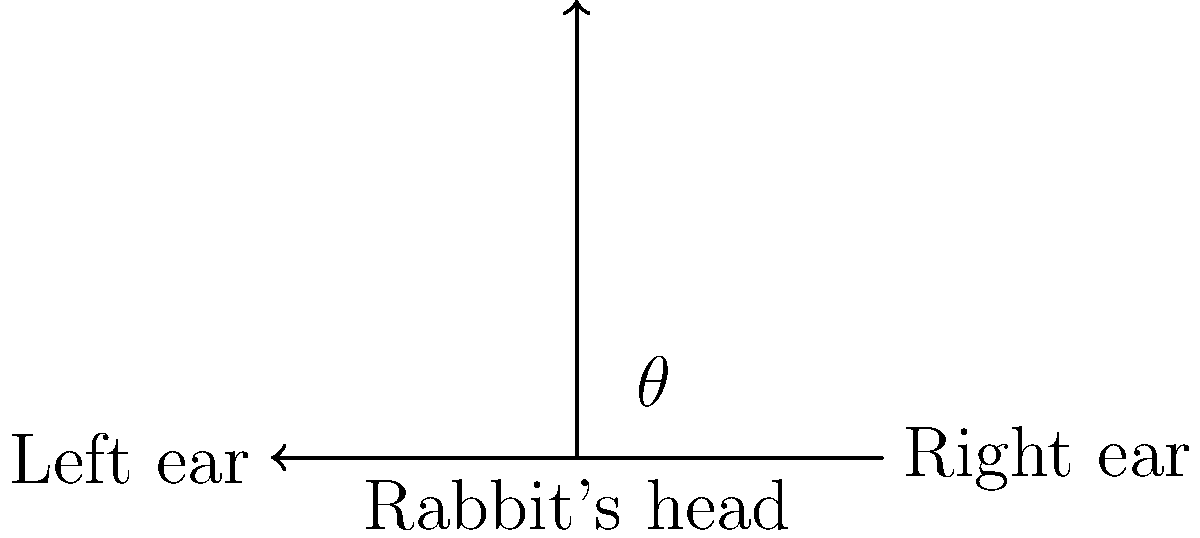At the pet store, you notice a curious rabbit with alert ears. If the angle between its ears is 120°, what is the measure of the angle $\theta$ between each ear and the vertical axis, as shown in the diagram? Let's approach this step-by-step:

1) First, recall that the sum of angles in a triangle is always 180°.

2) In this case, we have an isosceles triangle formed by the rabbit's ears and an imaginary vertical line.

3) Let's call the angle between the ears $\alpha$. We're given that $\alpha = 120°$.

4) The remaining angle at the top of the triangle is $180° - 120° = 60°$.

5) Since the triangle is isosceles (the ears are symmetrical), this 60° angle is split equally between the two base angles.

6) Therefore, each base angle (which we called $\theta$) is $60° \div 2 = 30°$.

7) We can verify: $30° + 30° + 120° = 180°$, which satisfies the triangle angle sum theorem.

Thus, the angle $\theta$ between each ear and the vertical axis is 30°.
Answer: $30°$ 